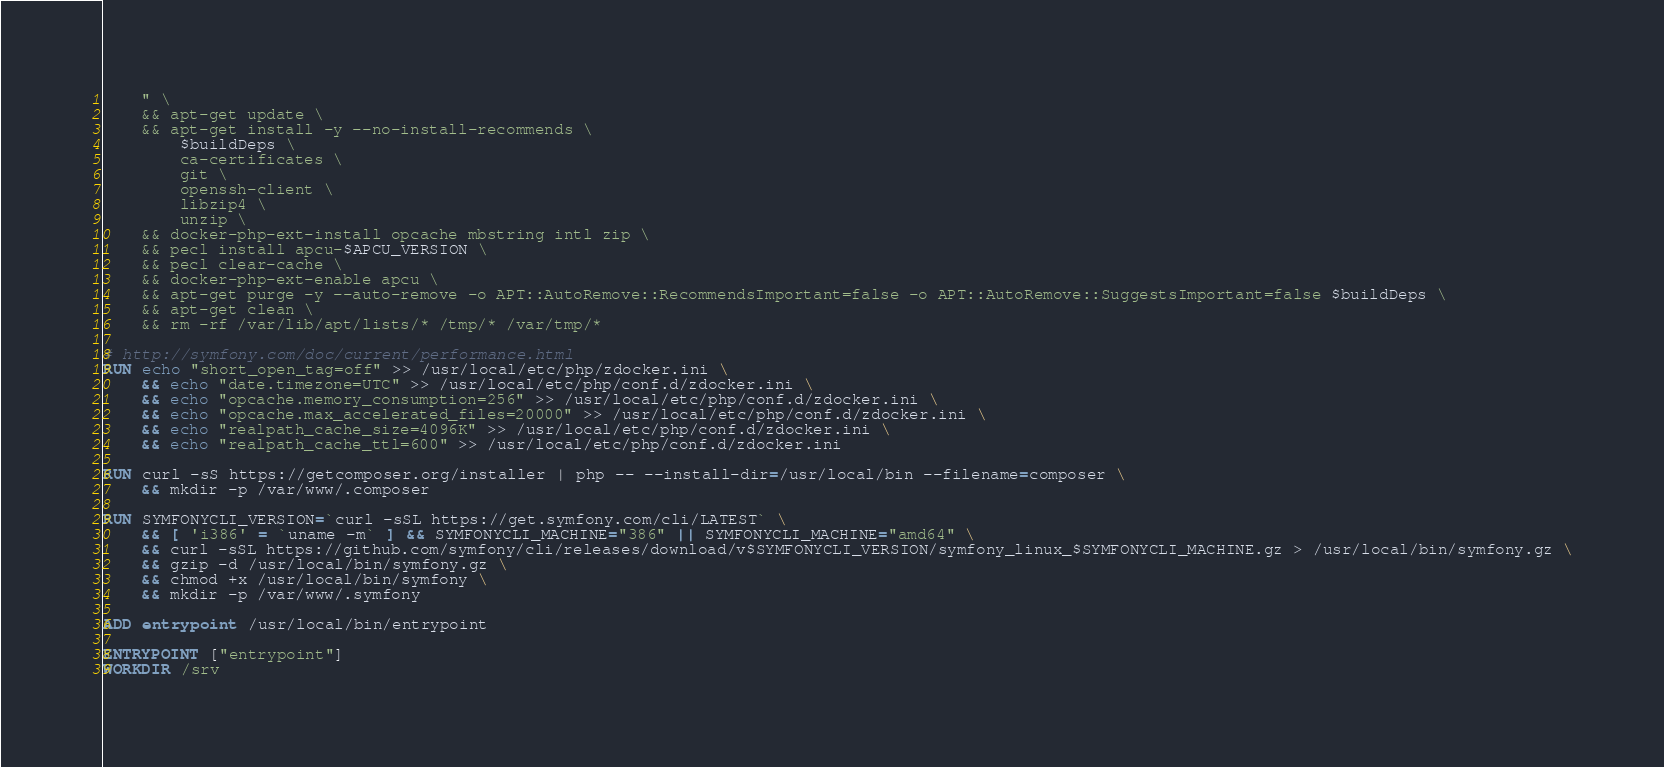<code> <loc_0><loc_0><loc_500><loc_500><_Dockerfile_>    " \
    && apt-get update \
    && apt-get install -y --no-install-recommends \
        $buildDeps \
        ca-certificates \
        git \
        openssh-client \
        libzip4 \
        unzip \
    && docker-php-ext-install opcache mbstring intl zip \
    && pecl install apcu-$APCU_VERSION \
    && pecl clear-cache \
    && docker-php-ext-enable apcu \
    && apt-get purge -y --auto-remove -o APT::AutoRemove::RecommendsImportant=false -o APT::AutoRemove::SuggestsImportant=false $buildDeps \
    && apt-get clean \
    && rm -rf /var/lib/apt/lists/* /tmp/* /var/tmp/*

# http://symfony.com/doc/current/performance.html
RUN echo "short_open_tag=off" >> /usr/local/etc/php/zdocker.ini \
    && echo "date.timezone=UTC" >> /usr/local/etc/php/conf.d/zdocker.ini \
    && echo "opcache.memory_consumption=256" >> /usr/local/etc/php/conf.d/zdocker.ini \
    && echo "opcache.max_accelerated_files=20000" >> /usr/local/etc/php/conf.d/zdocker.ini \
    && echo "realpath_cache_size=4096K" >> /usr/local/etc/php/conf.d/zdocker.ini \
    && echo "realpath_cache_ttl=600" >> /usr/local/etc/php/conf.d/zdocker.ini

RUN curl -sS https://getcomposer.org/installer | php -- --install-dir=/usr/local/bin --filename=composer \
    && mkdir -p /var/www/.composer

RUN SYMFONYCLI_VERSION=`curl -sSL https://get.symfony.com/cli/LATEST` \
    && [ 'i386' = `uname -m` ] && SYMFONYCLI_MACHINE="386" || SYMFONYCLI_MACHINE="amd64" \
    && curl -sSL https://github.com/symfony/cli/releases/download/v$SYMFONYCLI_VERSION/symfony_linux_$SYMFONYCLI_MACHINE.gz > /usr/local/bin/symfony.gz \
    && gzip -d /usr/local/bin/symfony.gz \
    && chmod +x /usr/local/bin/symfony \
    && mkdir -p /var/www/.symfony

ADD entrypoint /usr/local/bin/entrypoint

ENTRYPOINT ["entrypoint"]
WORKDIR /srv
</code> 